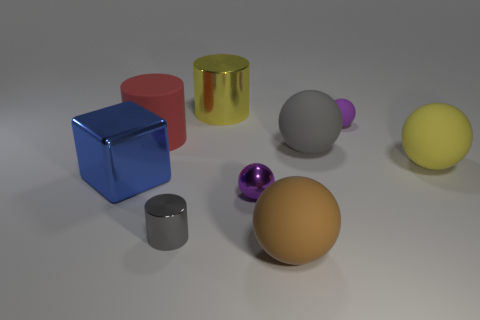There is a small metal object that is the same shape as the large brown rubber thing; what color is it?
Your answer should be very brief. Purple. Is there any other thing of the same color as the tiny matte thing?
Offer a terse response. Yes. There is a purple sphere that is behind the blue thing; what size is it?
Offer a very short reply. Small. There is a big metal cylinder; is its color the same as the big matte object right of the big gray matte thing?
Ensure brevity in your answer.  Yes. How many other things are made of the same material as the blue thing?
Offer a terse response. 3. Is the number of tiny objects greater than the number of large rubber things?
Provide a succinct answer. No. Does the tiny thing that is on the right side of the big brown sphere have the same color as the metal sphere?
Provide a short and direct response. Yes. What color is the cube?
Your response must be concise. Blue. Are there any brown rubber things left of the yellow object that is right of the gray rubber ball?
Make the answer very short. Yes. There is a big metallic object to the left of the yellow object to the left of the big brown thing; what shape is it?
Ensure brevity in your answer.  Cube. 